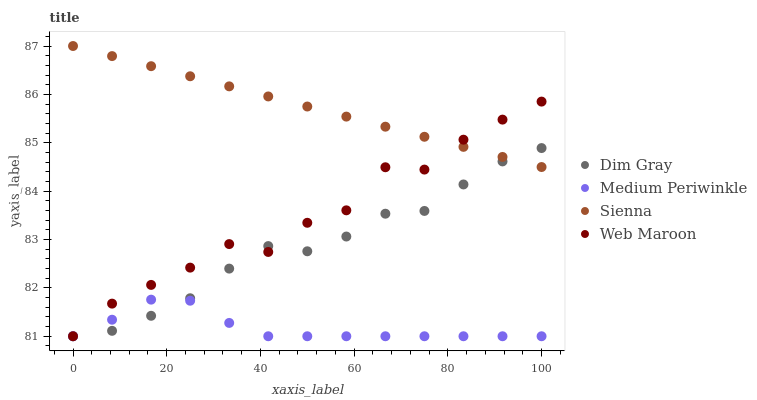Does Medium Periwinkle have the minimum area under the curve?
Answer yes or no. Yes. Does Sienna have the maximum area under the curve?
Answer yes or no. Yes. Does Web Maroon have the minimum area under the curve?
Answer yes or no. No. Does Web Maroon have the maximum area under the curve?
Answer yes or no. No. Is Sienna the smoothest?
Answer yes or no. Yes. Is Web Maroon the roughest?
Answer yes or no. Yes. Is Dim Gray the smoothest?
Answer yes or no. No. Is Dim Gray the roughest?
Answer yes or no. No. Does Web Maroon have the lowest value?
Answer yes or no. Yes. Does Sienna have the highest value?
Answer yes or no. Yes. Does Web Maroon have the highest value?
Answer yes or no. No. Is Medium Periwinkle less than Sienna?
Answer yes or no. Yes. Is Sienna greater than Medium Periwinkle?
Answer yes or no. Yes. Does Web Maroon intersect Sienna?
Answer yes or no. Yes. Is Web Maroon less than Sienna?
Answer yes or no. No. Is Web Maroon greater than Sienna?
Answer yes or no. No. Does Medium Periwinkle intersect Sienna?
Answer yes or no. No. 